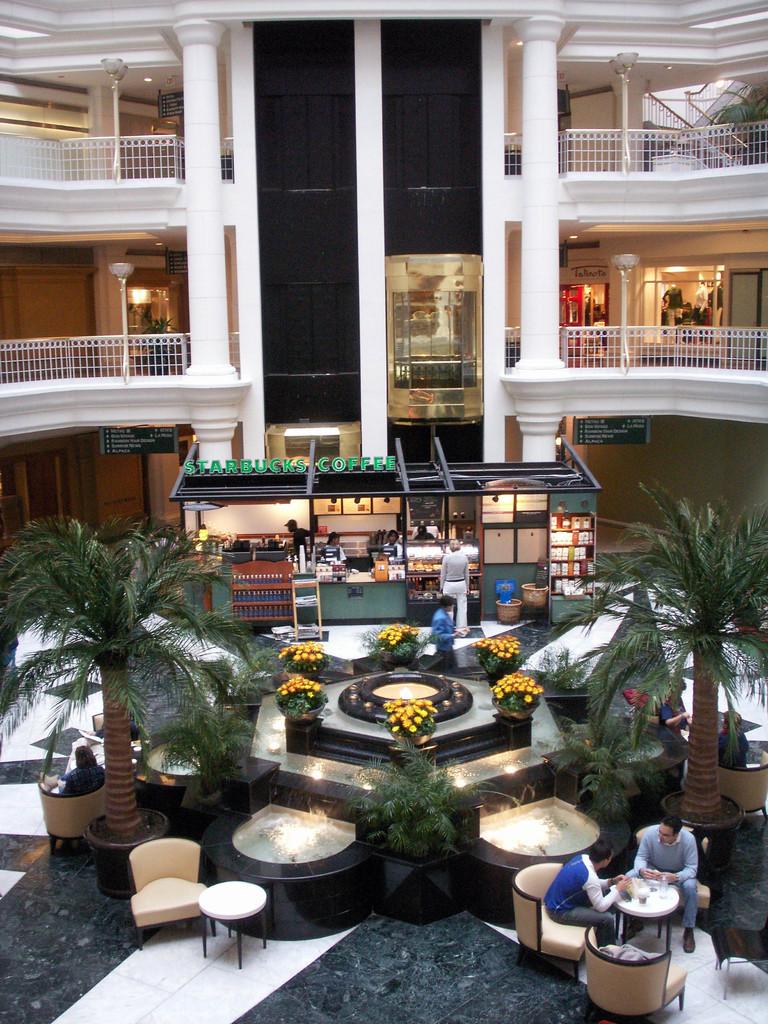What is the second word on the shop?
Offer a very short reply. Coffee. 